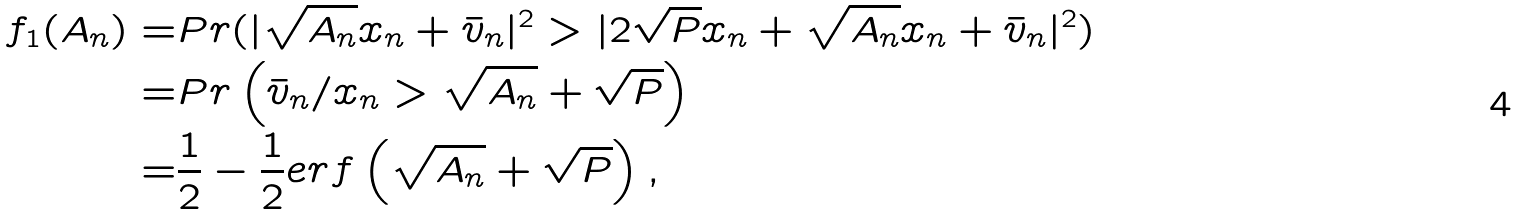<formula> <loc_0><loc_0><loc_500><loc_500>f _ { 1 } ( A _ { n } ) = & P r ( | \sqrt { A _ { n } } x _ { n } + \bar { v } _ { n } | ^ { 2 } > | 2 \sqrt { P } x _ { n } + \sqrt { A _ { n } } x _ { n } + \bar { v } _ { n } | ^ { 2 } ) \\ = & P r \left ( \bar { v } _ { n } / x _ { n } > \sqrt { A _ { n } } + \sqrt { P } \right ) \\ = & \frac { 1 } { 2 } - \frac { 1 } { 2 } e r f \left ( \sqrt { A _ { n } } + \sqrt { P } \right ) ,</formula> 